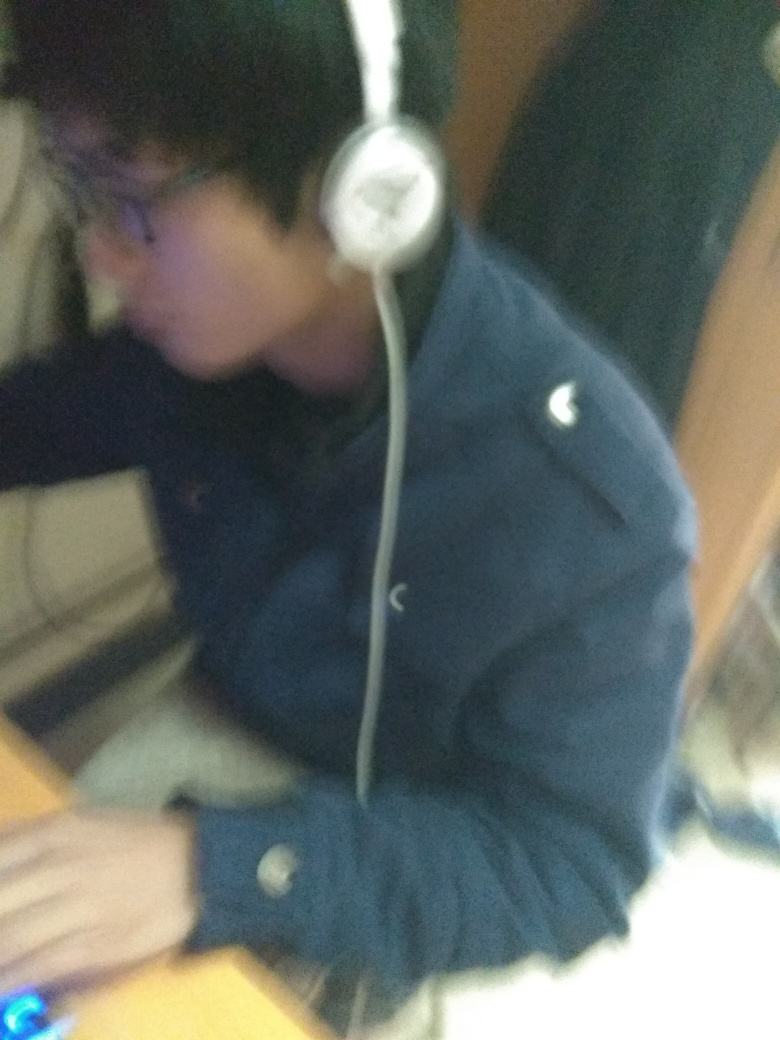Is the image sharp? The image is not sharp; it appears to be blurred, which may be due to motion blur or focus issues when the photo was taken. This reduces the clarity and detail that can be seen. 